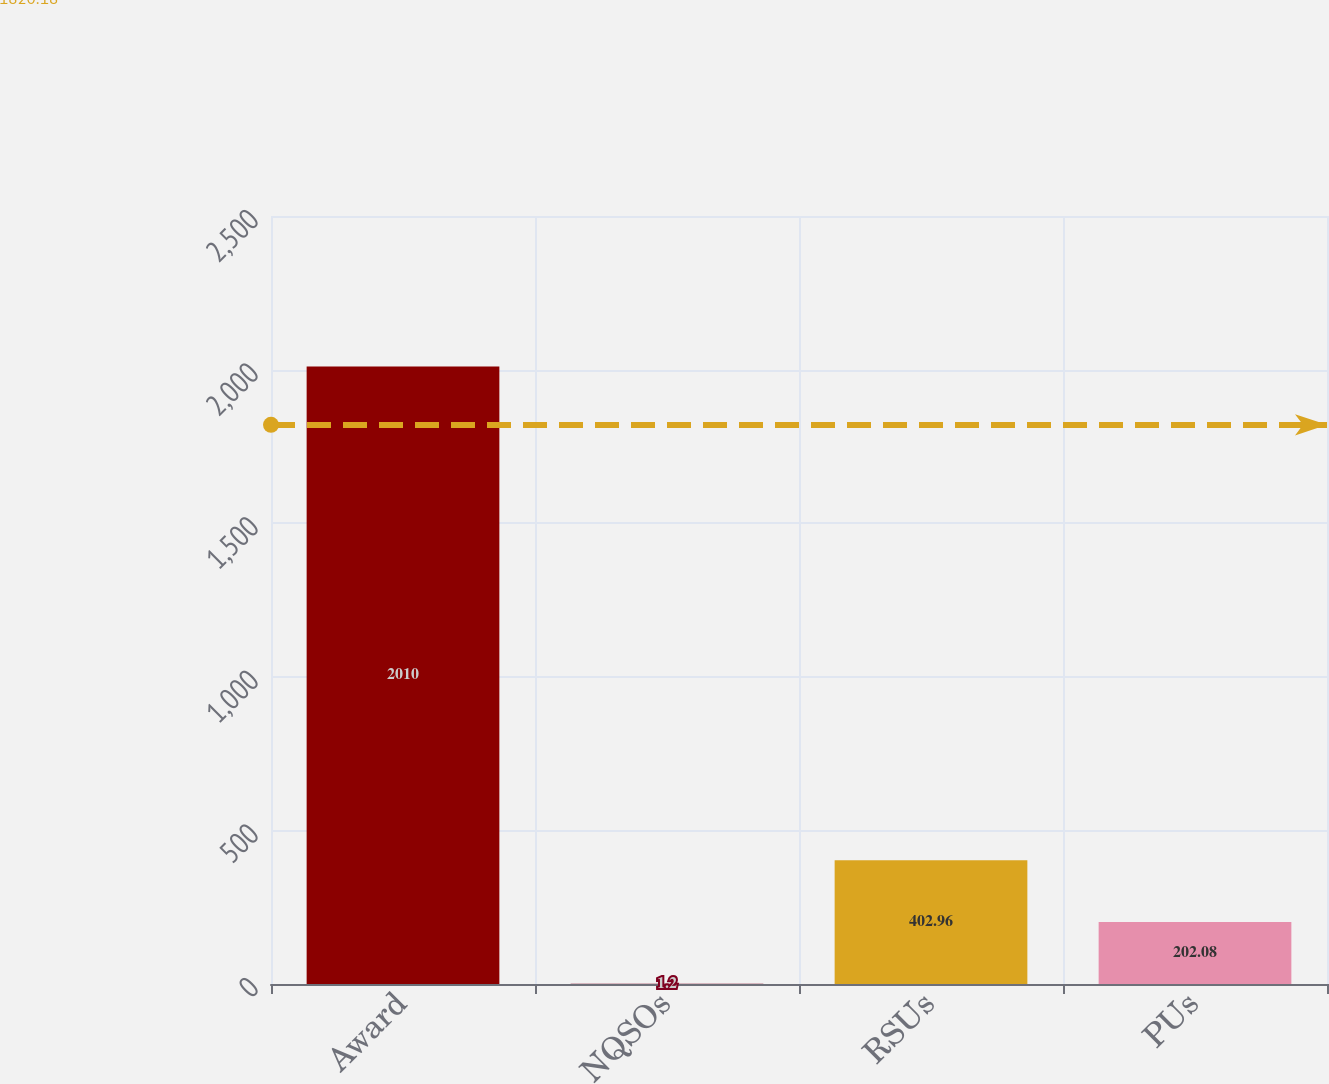Convert chart to OTSL. <chart><loc_0><loc_0><loc_500><loc_500><bar_chart><fcel>Award<fcel>NQSOs<fcel>RSUs<fcel>PUs<nl><fcel>2010<fcel>1.2<fcel>402.96<fcel>202.08<nl></chart> 